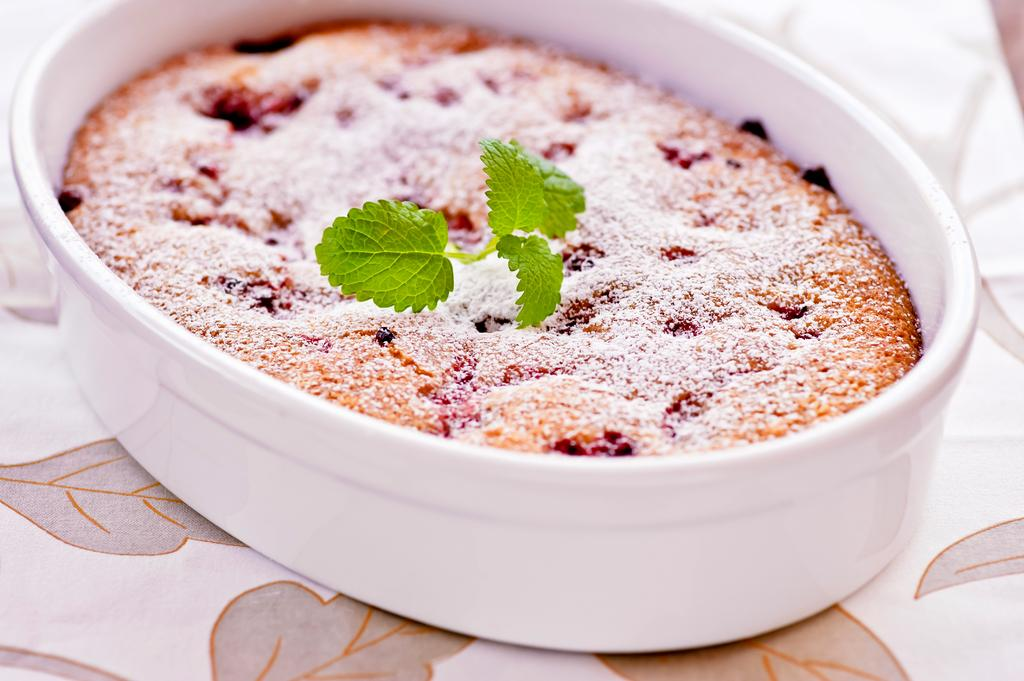What is in the bowl that is visible in the image? There is a bowl containing food in the image. What type of herb is present in the bowl? Mint leaves are present in the bowl. Where is the bowl located in the image? The bowl is placed on a table. What is covering the table in the image? The table is covered with a white cloth. What is the governor doing in the image? There is no governor present in the image. How many arms are visible in the image? The image does not show any arms; it only features a bowl, mint leaves, a table, and a white tablecloth. 